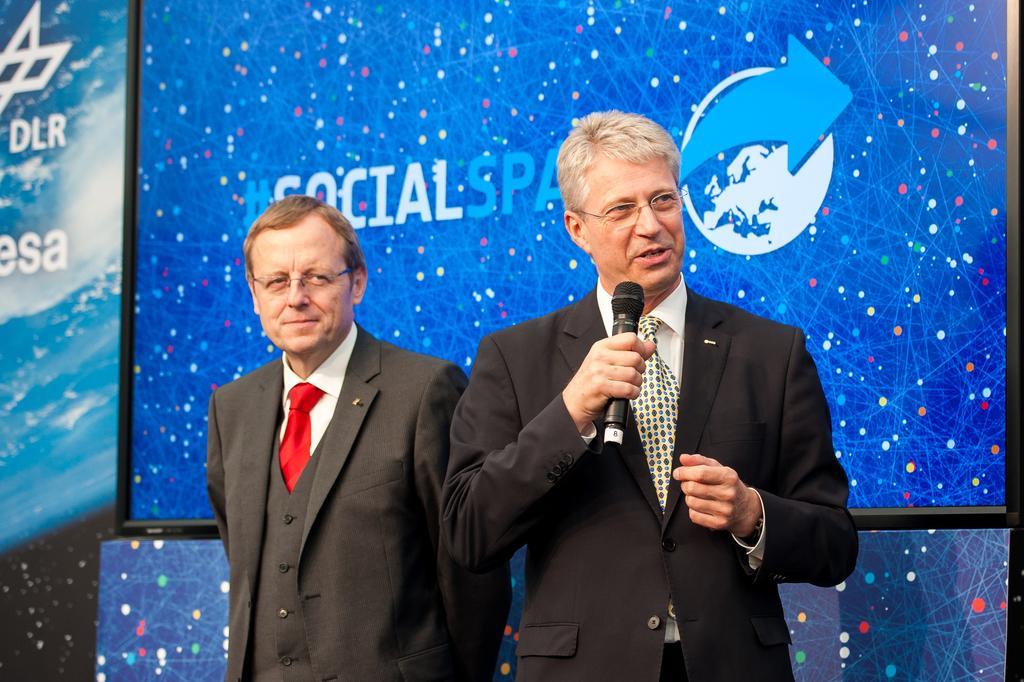Can you describe this image briefly? 2 men are standing wearing suit. The person at the right is holding a microphone. 